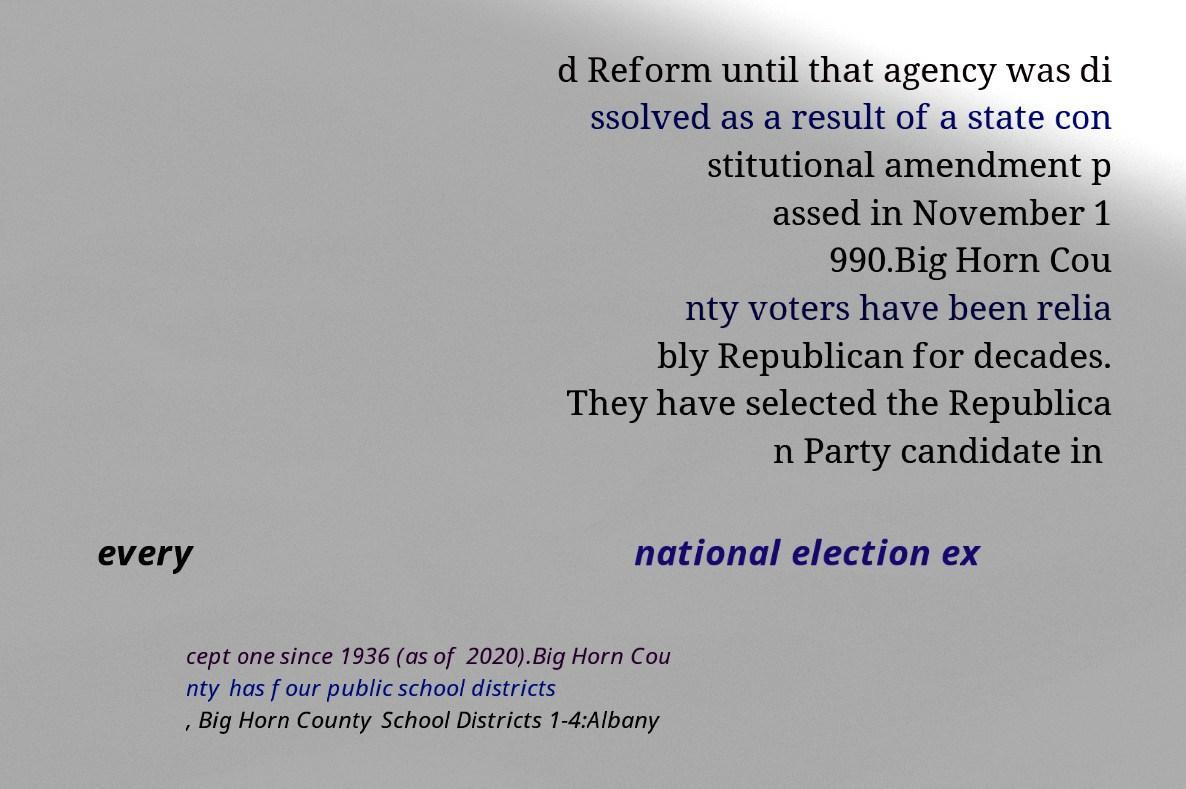What messages or text are displayed in this image? I need them in a readable, typed format. d Reform until that agency was di ssolved as a result of a state con stitutional amendment p assed in November 1 990.Big Horn Cou nty voters have been relia bly Republican for decades. They have selected the Republica n Party candidate in every national election ex cept one since 1936 (as of 2020).Big Horn Cou nty has four public school districts , Big Horn County School Districts 1-4:Albany 